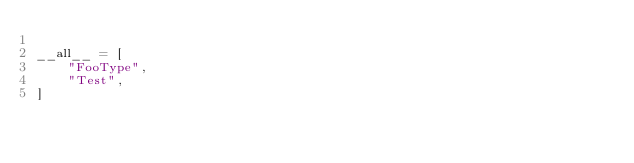<code> <loc_0><loc_0><loc_500><loc_500><_Python_>
__all__ = [
    "FooType",
    "Test",
]
</code> 